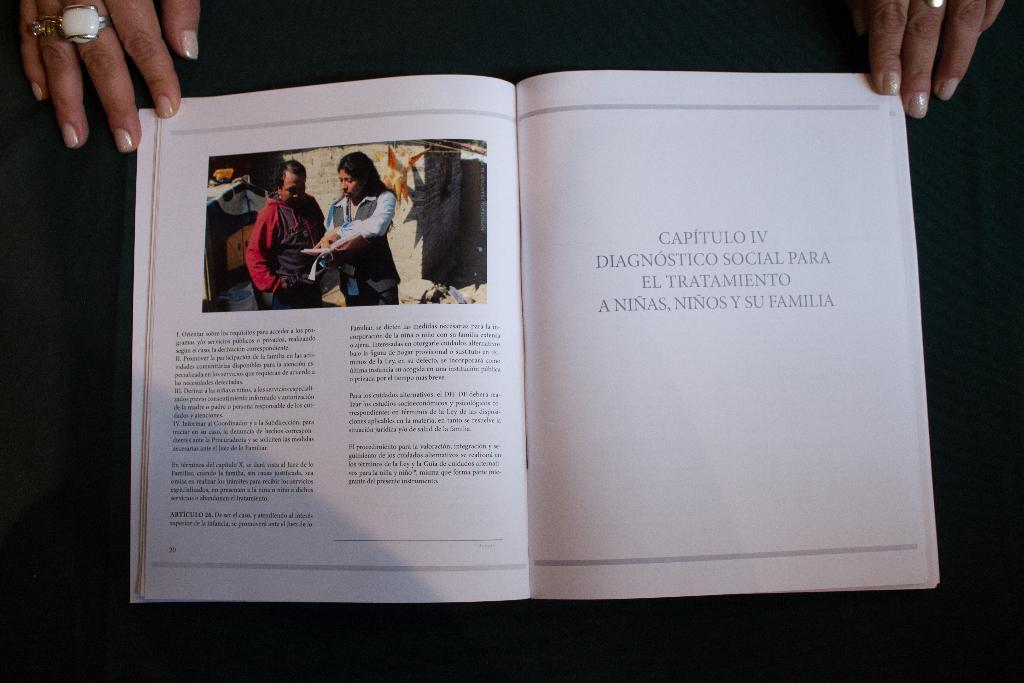What object is on the table in the image? There is a book on a table in the image. What is depicted in the book? The book contains a picture of two people. What action is being performed with the book in the image? Hands are touching the book in the image. What type of roll can be seen in the basin in the image? There is no roll or basin present in the image; it only features a book on a table with hands touching it. 